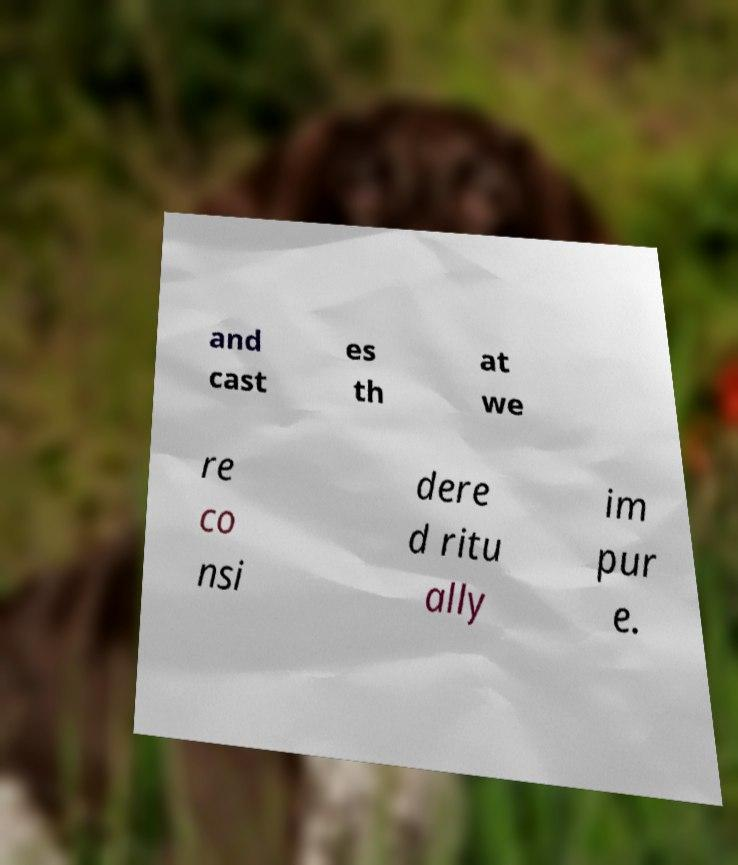Could you extract and type out the text from this image? and cast es th at we re co nsi dere d ritu ally im pur e. 